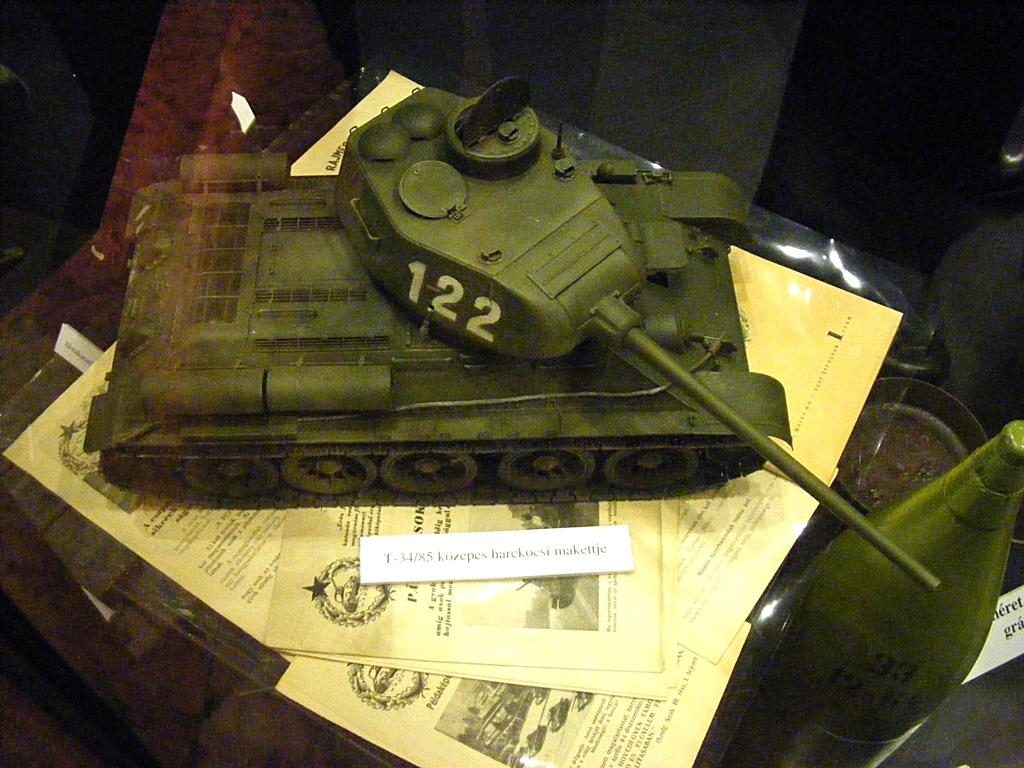What type of objects can be seen in the image? There are papers and an armored car in the image. Can you describe the armored car in the image? The armored car is a vehicle designed for protection and security. What is the color of the background in the image? The background of the image is dark. How many objects can be seen in the image? There are at least two objects visible in the image: papers and an armored car. What type of shoes is the person wearing while thinking in the image? There is no person wearing shoes or thinking in the image; it only contains papers and an armored car. 